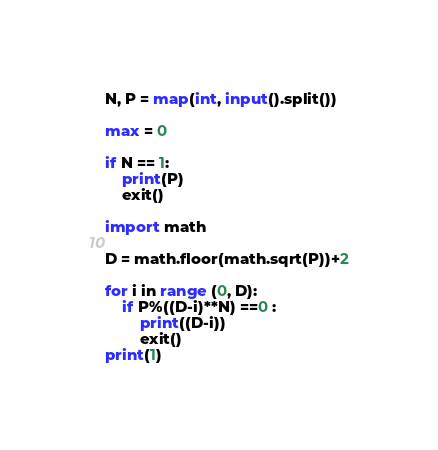<code> <loc_0><loc_0><loc_500><loc_500><_Python_>N, P = map(int, input().split())

max = 0

if N == 1:
    print(P)
    exit()

import math

D = math.floor(math.sqrt(P))+2

for i in range (0, D):
    if P%((D-i)**N) ==0 :
        print((D-i))
        exit()
print(1)</code> 